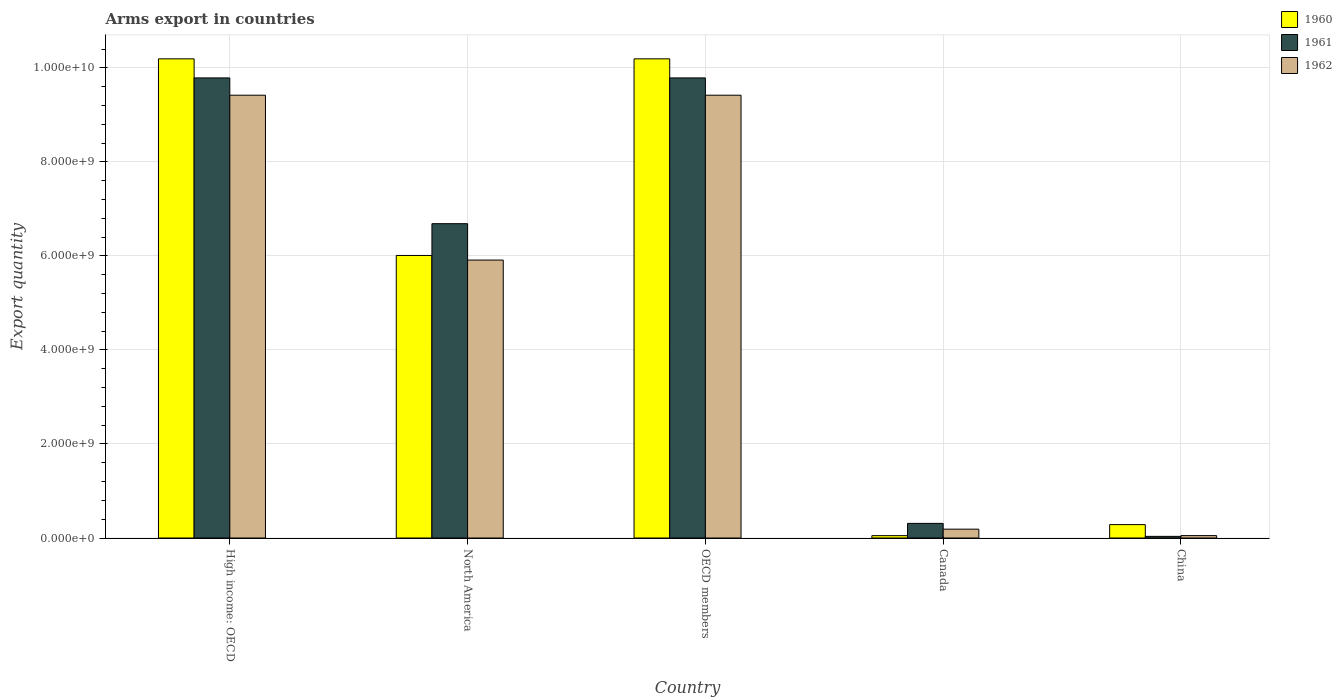How many different coloured bars are there?
Provide a succinct answer. 3. How many groups of bars are there?
Your answer should be compact. 5. Are the number of bars per tick equal to the number of legend labels?
Your answer should be compact. Yes. Are the number of bars on each tick of the X-axis equal?
Your response must be concise. Yes. What is the label of the 4th group of bars from the left?
Make the answer very short. Canada. What is the total arms export in 1961 in North America?
Your answer should be compact. 6.69e+09. Across all countries, what is the maximum total arms export in 1960?
Offer a terse response. 1.02e+1. Across all countries, what is the minimum total arms export in 1962?
Offer a very short reply. 5.10e+07. In which country was the total arms export in 1960 maximum?
Give a very brief answer. High income: OECD. In which country was the total arms export in 1962 minimum?
Keep it short and to the point. China. What is the total total arms export in 1960 in the graph?
Offer a very short reply. 2.67e+1. What is the difference between the total arms export in 1961 in Canada and that in High income: OECD?
Your answer should be very brief. -9.48e+09. What is the difference between the total arms export in 1961 in OECD members and the total arms export in 1962 in Canada?
Keep it short and to the point. 9.60e+09. What is the average total arms export in 1962 per country?
Provide a succinct answer. 5.00e+09. What is the difference between the total arms export of/in 1961 and total arms export of/in 1962 in Canada?
Offer a terse response. 1.23e+08. In how many countries, is the total arms export in 1962 greater than 10000000000?
Offer a very short reply. 0. What is the ratio of the total arms export in 1960 in Canada to that in High income: OECD?
Your answer should be very brief. 0. Is the total arms export in 1962 in China less than that in High income: OECD?
Offer a terse response. Yes. Is the difference between the total arms export in 1961 in Canada and China greater than the difference between the total arms export in 1962 in Canada and China?
Your answer should be very brief. Yes. What is the difference between the highest and the second highest total arms export in 1960?
Keep it short and to the point. 4.18e+09. What is the difference between the highest and the lowest total arms export in 1961?
Your answer should be compact. 9.75e+09. Is the sum of the total arms export in 1962 in Canada and OECD members greater than the maximum total arms export in 1960 across all countries?
Your answer should be compact. No. Are the values on the major ticks of Y-axis written in scientific E-notation?
Give a very brief answer. Yes. Does the graph contain any zero values?
Your answer should be compact. No. What is the title of the graph?
Give a very brief answer. Arms export in countries. Does "2010" appear as one of the legend labels in the graph?
Provide a short and direct response. No. What is the label or title of the X-axis?
Give a very brief answer. Country. What is the label or title of the Y-axis?
Keep it short and to the point. Export quantity. What is the Export quantity in 1960 in High income: OECD?
Offer a terse response. 1.02e+1. What is the Export quantity in 1961 in High income: OECD?
Your response must be concise. 9.79e+09. What is the Export quantity of 1962 in High income: OECD?
Make the answer very short. 9.42e+09. What is the Export quantity of 1960 in North America?
Offer a terse response. 6.01e+09. What is the Export quantity in 1961 in North America?
Give a very brief answer. 6.69e+09. What is the Export quantity in 1962 in North America?
Your answer should be compact. 5.91e+09. What is the Export quantity of 1960 in OECD members?
Your response must be concise. 1.02e+1. What is the Export quantity of 1961 in OECD members?
Make the answer very short. 9.79e+09. What is the Export quantity of 1962 in OECD members?
Offer a very short reply. 9.42e+09. What is the Export quantity of 1961 in Canada?
Offer a terse response. 3.11e+08. What is the Export quantity in 1962 in Canada?
Make the answer very short. 1.88e+08. What is the Export quantity in 1960 in China?
Provide a succinct answer. 2.85e+08. What is the Export quantity in 1961 in China?
Offer a very short reply. 3.50e+07. What is the Export quantity of 1962 in China?
Provide a succinct answer. 5.10e+07. Across all countries, what is the maximum Export quantity of 1960?
Offer a very short reply. 1.02e+1. Across all countries, what is the maximum Export quantity in 1961?
Provide a succinct answer. 9.79e+09. Across all countries, what is the maximum Export quantity in 1962?
Your answer should be compact. 9.42e+09. Across all countries, what is the minimum Export quantity of 1961?
Offer a very short reply. 3.50e+07. Across all countries, what is the minimum Export quantity in 1962?
Provide a succinct answer. 5.10e+07. What is the total Export quantity in 1960 in the graph?
Make the answer very short. 2.67e+1. What is the total Export quantity of 1961 in the graph?
Your answer should be compact. 2.66e+1. What is the total Export quantity of 1962 in the graph?
Keep it short and to the point. 2.50e+1. What is the difference between the Export quantity in 1960 in High income: OECD and that in North America?
Give a very brief answer. 4.18e+09. What is the difference between the Export quantity in 1961 in High income: OECD and that in North America?
Make the answer very short. 3.10e+09. What is the difference between the Export quantity of 1962 in High income: OECD and that in North America?
Your response must be concise. 3.51e+09. What is the difference between the Export quantity in 1962 in High income: OECD and that in OECD members?
Make the answer very short. 0. What is the difference between the Export quantity in 1960 in High income: OECD and that in Canada?
Provide a short and direct response. 1.01e+1. What is the difference between the Export quantity of 1961 in High income: OECD and that in Canada?
Your response must be concise. 9.48e+09. What is the difference between the Export quantity of 1962 in High income: OECD and that in Canada?
Offer a terse response. 9.23e+09. What is the difference between the Export quantity of 1960 in High income: OECD and that in China?
Give a very brief answer. 9.91e+09. What is the difference between the Export quantity of 1961 in High income: OECD and that in China?
Give a very brief answer. 9.75e+09. What is the difference between the Export quantity of 1962 in High income: OECD and that in China?
Your response must be concise. 9.37e+09. What is the difference between the Export quantity of 1960 in North America and that in OECD members?
Provide a succinct answer. -4.18e+09. What is the difference between the Export quantity in 1961 in North America and that in OECD members?
Give a very brief answer. -3.10e+09. What is the difference between the Export quantity in 1962 in North America and that in OECD members?
Give a very brief answer. -3.51e+09. What is the difference between the Export quantity in 1960 in North America and that in Canada?
Offer a very short reply. 5.96e+09. What is the difference between the Export quantity in 1961 in North America and that in Canada?
Your response must be concise. 6.38e+09. What is the difference between the Export quantity of 1962 in North America and that in Canada?
Your answer should be compact. 5.72e+09. What is the difference between the Export quantity in 1960 in North America and that in China?
Ensure brevity in your answer.  5.73e+09. What is the difference between the Export quantity of 1961 in North America and that in China?
Make the answer very short. 6.65e+09. What is the difference between the Export quantity of 1962 in North America and that in China?
Make the answer very short. 5.86e+09. What is the difference between the Export quantity in 1960 in OECD members and that in Canada?
Ensure brevity in your answer.  1.01e+1. What is the difference between the Export quantity in 1961 in OECD members and that in Canada?
Your response must be concise. 9.48e+09. What is the difference between the Export quantity in 1962 in OECD members and that in Canada?
Offer a terse response. 9.23e+09. What is the difference between the Export quantity of 1960 in OECD members and that in China?
Ensure brevity in your answer.  9.91e+09. What is the difference between the Export quantity of 1961 in OECD members and that in China?
Make the answer very short. 9.75e+09. What is the difference between the Export quantity of 1962 in OECD members and that in China?
Provide a succinct answer. 9.37e+09. What is the difference between the Export quantity in 1960 in Canada and that in China?
Offer a very short reply. -2.35e+08. What is the difference between the Export quantity of 1961 in Canada and that in China?
Offer a very short reply. 2.76e+08. What is the difference between the Export quantity in 1962 in Canada and that in China?
Your answer should be compact. 1.37e+08. What is the difference between the Export quantity of 1960 in High income: OECD and the Export quantity of 1961 in North America?
Your answer should be very brief. 3.51e+09. What is the difference between the Export quantity of 1960 in High income: OECD and the Export quantity of 1962 in North America?
Your answer should be very brief. 4.28e+09. What is the difference between the Export quantity in 1961 in High income: OECD and the Export quantity in 1962 in North America?
Offer a terse response. 3.88e+09. What is the difference between the Export quantity in 1960 in High income: OECD and the Export quantity in 1961 in OECD members?
Provide a succinct answer. 4.06e+08. What is the difference between the Export quantity of 1960 in High income: OECD and the Export quantity of 1962 in OECD members?
Offer a very short reply. 7.74e+08. What is the difference between the Export quantity of 1961 in High income: OECD and the Export quantity of 1962 in OECD members?
Your answer should be very brief. 3.68e+08. What is the difference between the Export quantity of 1960 in High income: OECD and the Export quantity of 1961 in Canada?
Provide a short and direct response. 9.88e+09. What is the difference between the Export quantity of 1960 in High income: OECD and the Export quantity of 1962 in Canada?
Ensure brevity in your answer.  1.00e+1. What is the difference between the Export quantity of 1961 in High income: OECD and the Export quantity of 1962 in Canada?
Your answer should be compact. 9.60e+09. What is the difference between the Export quantity of 1960 in High income: OECD and the Export quantity of 1961 in China?
Give a very brief answer. 1.02e+1. What is the difference between the Export quantity in 1960 in High income: OECD and the Export quantity in 1962 in China?
Your answer should be very brief. 1.01e+1. What is the difference between the Export quantity of 1961 in High income: OECD and the Export quantity of 1962 in China?
Ensure brevity in your answer.  9.74e+09. What is the difference between the Export quantity of 1960 in North America and the Export quantity of 1961 in OECD members?
Make the answer very short. -3.78e+09. What is the difference between the Export quantity in 1960 in North America and the Export quantity in 1962 in OECD members?
Your answer should be compact. -3.41e+09. What is the difference between the Export quantity in 1961 in North America and the Export quantity in 1962 in OECD members?
Give a very brief answer. -2.73e+09. What is the difference between the Export quantity in 1960 in North America and the Export quantity in 1961 in Canada?
Give a very brief answer. 5.70e+09. What is the difference between the Export quantity of 1960 in North America and the Export quantity of 1962 in Canada?
Your response must be concise. 5.82e+09. What is the difference between the Export quantity of 1961 in North America and the Export quantity of 1962 in Canada?
Your answer should be very brief. 6.50e+09. What is the difference between the Export quantity in 1960 in North America and the Export quantity in 1961 in China?
Your response must be concise. 5.98e+09. What is the difference between the Export quantity in 1960 in North America and the Export quantity in 1962 in China?
Provide a succinct answer. 5.96e+09. What is the difference between the Export quantity in 1961 in North America and the Export quantity in 1962 in China?
Your answer should be compact. 6.64e+09. What is the difference between the Export quantity in 1960 in OECD members and the Export quantity in 1961 in Canada?
Give a very brief answer. 9.88e+09. What is the difference between the Export quantity in 1960 in OECD members and the Export quantity in 1962 in Canada?
Your response must be concise. 1.00e+1. What is the difference between the Export quantity of 1961 in OECD members and the Export quantity of 1962 in Canada?
Offer a terse response. 9.60e+09. What is the difference between the Export quantity in 1960 in OECD members and the Export quantity in 1961 in China?
Offer a terse response. 1.02e+1. What is the difference between the Export quantity of 1960 in OECD members and the Export quantity of 1962 in China?
Your response must be concise. 1.01e+1. What is the difference between the Export quantity in 1961 in OECD members and the Export quantity in 1962 in China?
Your response must be concise. 9.74e+09. What is the difference between the Export quantity in 1960 in Canada and the Export quantity in 1961 in China?
Ensure brevity in your answer.  1.50e+07. What is the difference between the Export quantity in 1961 in Canada and the Export quantity in 1962 in China?
Offer a terse response. 2.60e+08. What is the average Export quantity in 1960 per country?
Make the answer very short. 5.35e+09. What is the average Export quantity in 1961 per country?
Provide a short and direct response. 5.32e+09. What is the average Export quantity in 1962 per country?
Your answer should be compact. 5.00e+09. What is the difference between the Export quantity in 1960 and Export quantity in 1961 in High income: OECD?
Provide a succinct answer. 4.06e+08. What is the difference between the Export quantity of 1960 and Export quantity of 1962 in High income: OECD?
Ensure brevity in your answer.  7.74e+08. What is the difference between the Export quantity in 1961 and Export quantity in 1962 in High income: OECD?
Offer a terse response. 3.68e+08. What is the difference between the Export quantity of 1960 and Export quantity of 1961 in North America?
Offer a very short reply. -6.76e+08. What is the difference between the Export quantity of 1960 and Export quantity of 1962 in North America?
Offer a very short reply. 9.80e+07. What is the difference between the Export quantity of 1961 and Export quantity of 1962 in North America?
Provide a short and direct response. 7.74e+08. What is the difference between the Export quantity of 1960 and Export quantity of 1961 in OECD members?
Your answer should be very brief. 4.06e+08. What is the difference between the Export quantity in 1960 and Export quantity in 1962 in OECD members?
Offer a terse response. 7.74e+08. What is the difference between the Export quantity of 1961 and Export quantity of 1962 in OECD members?
Offer a terse response. 3.68e+08. What is the difference between the Export quantity in 1960 and Export quantity in 1961 in Canada?
Your answer should be compact. -2.61e+08. What is the difference between the Export quantity of 1960 and Export quantity of 1962 in Canada?
Keep it short and to the point. -1.38e+08. What is the difference between the Export quantity of 1961 and Export quantity of 1962 in Canada?
Keep it short and to the point. 1.23e+08. What is the difference between the Export quantity in 1960 and Export quantity in 1961 in China?
Provide a short and direct response. 2.50e+08. What is the difference between the Export quantity in 1960 and Export quantity in 1962 in China?
Provide a short and direct response. 2.34e+08. What is the difference between the Export quantity in 1961 and Export quantity in 1962 in China?
Ensure brevity in your answer.  -1.60e+07. What is the ratio of the Export quantity in 1960 in High income: OECD to that in North America?
Make the answer very short. 1.7. What is the ratio of the Export quantity of 1961 in High income: OECD to that in North America?
Your answer should be very brief. 1.46. What is the ratio of the Export quantity in 1962 in High income: OECD to that in North America?
Offer a terse response. 1.59. What is the ratio of the Export quantity in 1960 in High income: OECD to that in OECD members?
Provide a succinct answer. 1. What is the ratio of the Export quantity in 1960 in High income: OECD to that in Canada?
Offer a terse response. 203.88. What is the ratio of the Export quantity of 1961 in High income: OECD to that in Canada?
Offer a very short reply. 31.47. What is the ratio of the Export quantity of 1962 in High income: OECD to that in Canada?
Your answer should be very brief. 50.11. What is the ratio of the Export quantity of 1960 in High income: OECD to that in China?
Your response must be concise. 35.77. What is the ratio of the Export quantity in 1961 in High income: OECD to that in China?
Provide a succinct answer. 279.66. What is the ratio of the Export quantity of 1962 in High income: OECD to that in China?
Your answer should be compact. 184.71. What is the ratio of the Export quantity in 1960 in North America to that in OECD members?
Offer a terse response. 0.59. What is the ratio of the Export quantity of 1961 in North America to that in OECD members?
Your answer should be very brief. 0.68. What is the ratio of the Export quantity in 1962 in North America to that in OECD members?
Give a very brief answer. 0.63. What is the ratio of the Export quantity of 1960 in North America to that in Canada?
Offer a very short reply. 120.22. What is the ratio of the Export quantity in 1961 in North America to that in Canada?
Your answer should be compact. 21.5. What is the ratio of the Export quantity of 1962 in North America to that in Canada?
Give a very brief answer. 31.45. What is the ratio of the Export quantity of 1960 in North America to that in China?
Your answer should be compact. 21.09. What is the ratio of the Export quantity of 1961 in North America to that in China?
Ensure brevity in your answer.  191.06. What is the ratio of the Export quantity of 1962 in North America to that in China?
Make the answer very short. 115.94. What is the ratio of the Export quantity in 1960 in OECD members to that in Canada?
Offer a very short reply. 203.88. What is the ratio of the Export quantity in 1961 in OECD members to that in Canada?
Give a very brief answer. 31.47. What is the ratio of the Export quantity of 1962 in OECD members to that in Canada?
Your answer should be compact. 50.11. What is the ratio of the Export quantity of 1960 in OECD members to that in China?
Offer a terse response. 35.77. What is the ratio of the Export quantity in 1961 in OECD members to that in China?
Give a very brief answer. 279.66. What is the ratio of the Export quantity of 1962 in OECD members to that in China?
Your response must be concise. 184.71. What is the ratio of the Export quantity in 1960 in Canada to that in China?
Ensure brevity in your answer.  0.18. What is the ratio of the Export quantity of 1961 in Canada to that in China?
Offer a terse response. 8.89. What is the ratio of the Export quantity in 1962 in Canada to that in China?
Offer a very short reply. 3.69. What is the difference between the highest and the second highest Export quantity of 1960?
Your answer should be very brief. 0. What is the difference between the highest and the lowest Export quantity of 1960?
Provide a succinct answer. 1.01e+1. What is the difference between the highest and the lowest Export quantity in 1961?
Your answer should be very brief. 9.75e+09. What is the difference between the highest and the lowest Export quantity in 1962?
Make the answer very short. 9.37e+09. 